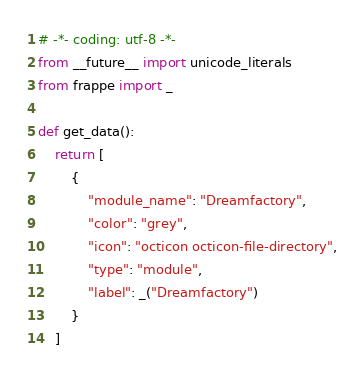<code> <loc_0><loc_0><loc_500><loc_500><_Python_># -*- coding: utf-8 -*-
from __future__ import unicode_literals
from frappe import _

def get_data():
	return [
		{
			"module_name": "Dreamfactory",
			"color": "grey",
			"icon": "octicon octicon-file-directory",
			"type": "module",
			"label": _("Dreamfactory")
		}
	]
</code> 